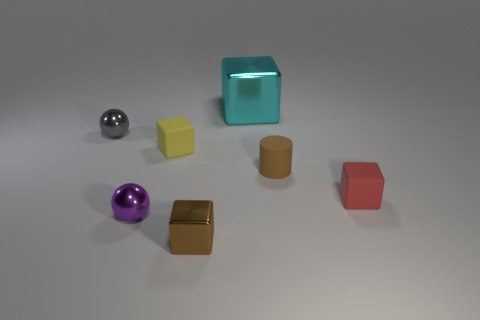Add 2 small brown metal things. How many objects exist? 9 Subtract all cubes. How many objects are left? 3 Subtract all purple balls. Subtract all small purple metal objects. How many objects are left? 5 Add 7 tiny brown objects. How many tiny brown objects are left? 9 Add 4 small red objects. How many small red objects exist? 5 Subtract 0 red cylinders. How many objects are left? 7 